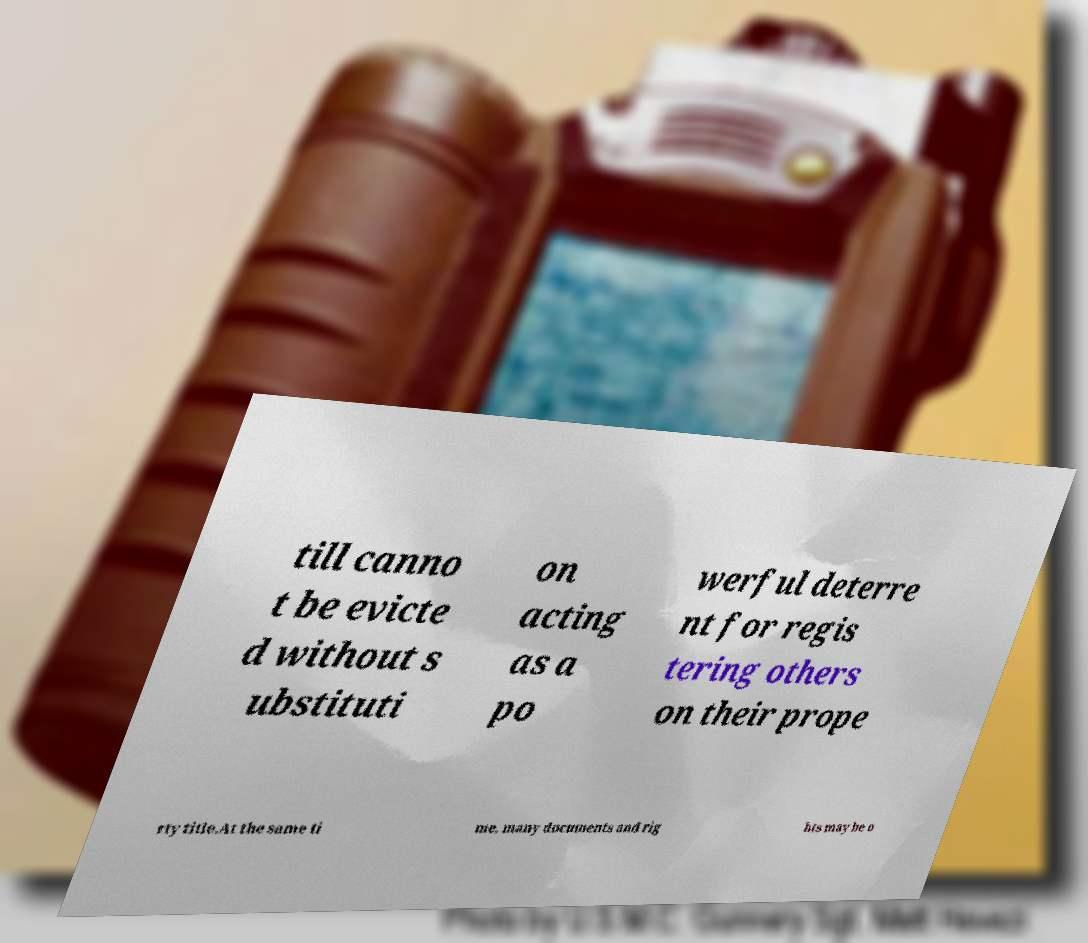There's text embedded in this image that I need extracted. Can you transcribe it verbatim? till canno t be evicte d without s ubstituti on acting as a po werful deterre nt for regis tering others on their prope rty title.At the same ti me, many documents and rig hts may be o 